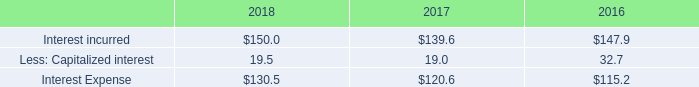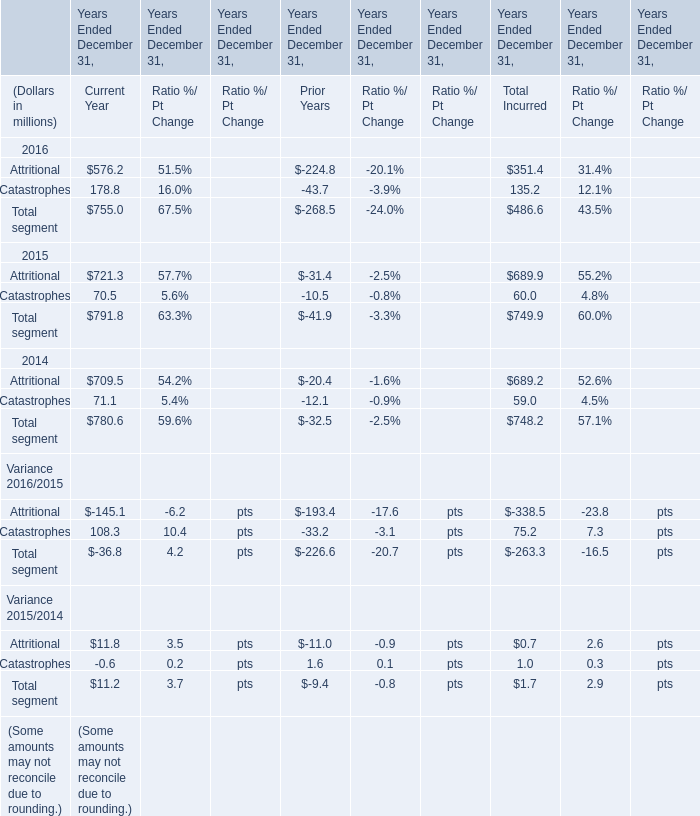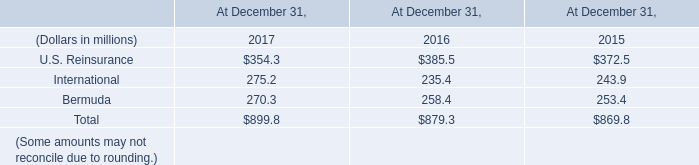what was the increase in the interest expenses during 2017 and 2018? 
Computations: ((130.5 / 120.6) - 1)
Answer: 0.08209. 